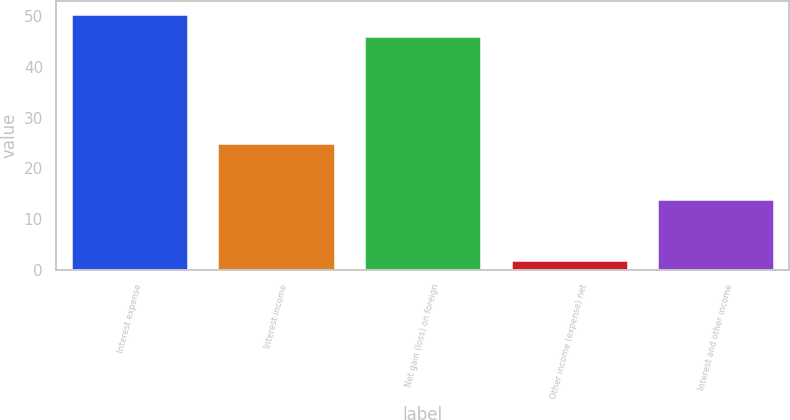Convert chart. <chart><loc_0><loc_0><loc_500><loc_500><bar_chart><fcel>Interest expense<fcel>Interest income<fcel>Net gain (loss) on foreign<fcel>Other income (expense) net<fcel>Interest and other income<nl><fcel>50.5<fcel>25<fcel>46<fcel>2<fcel>14<nl></chart> 